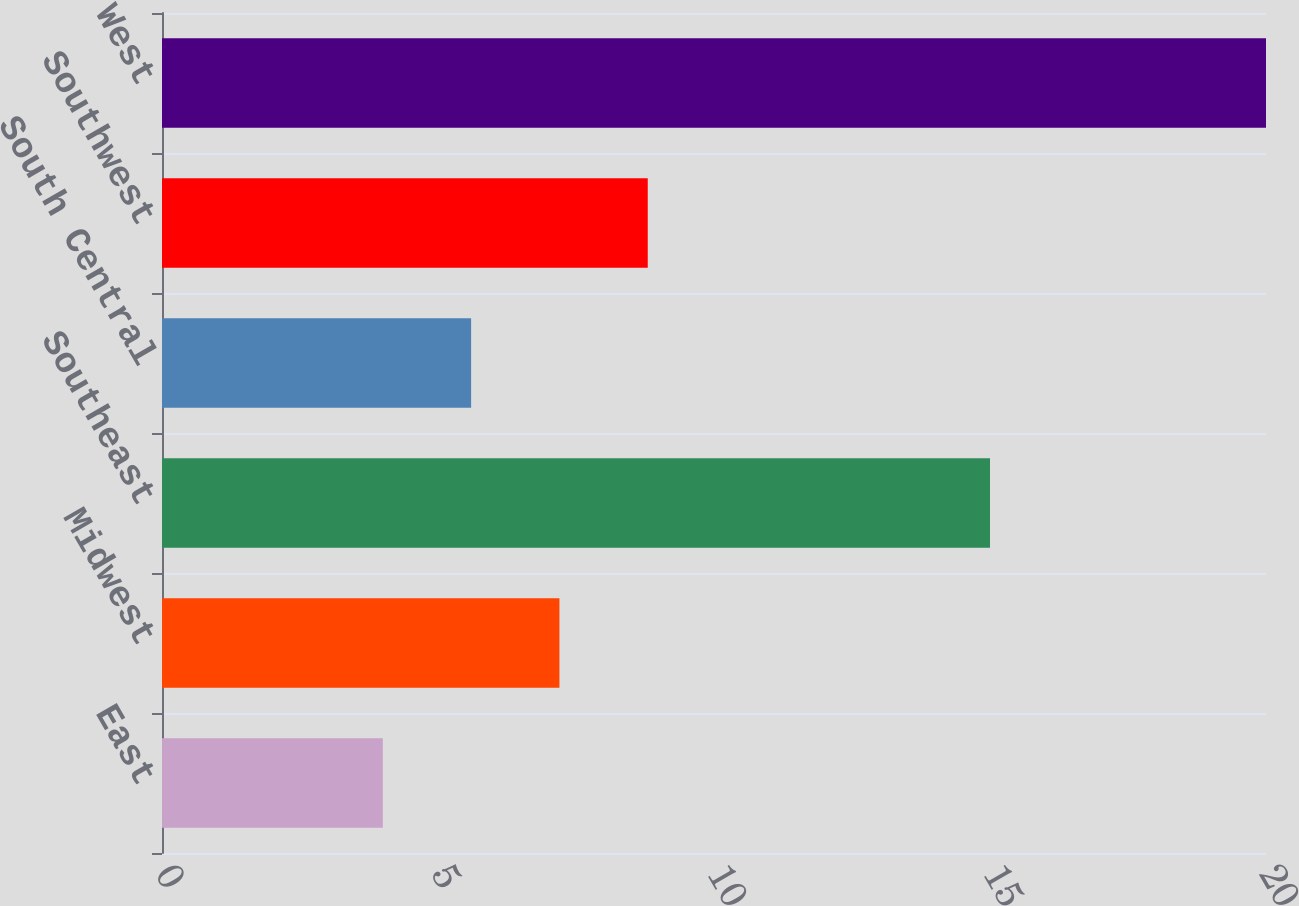Convert chart. <chart><loc_0><loc_0><loc_500><loc_500><bar_chart><fcel>East<fcel>Midwest<fcel>Southeast<fcel>South Central<fcel>Southwest<fcel>West<nl><fcel>4<fcel>7.2<fcel>15<fcel>5.6<fcel>8.8<fcel>20<nl></chart> 